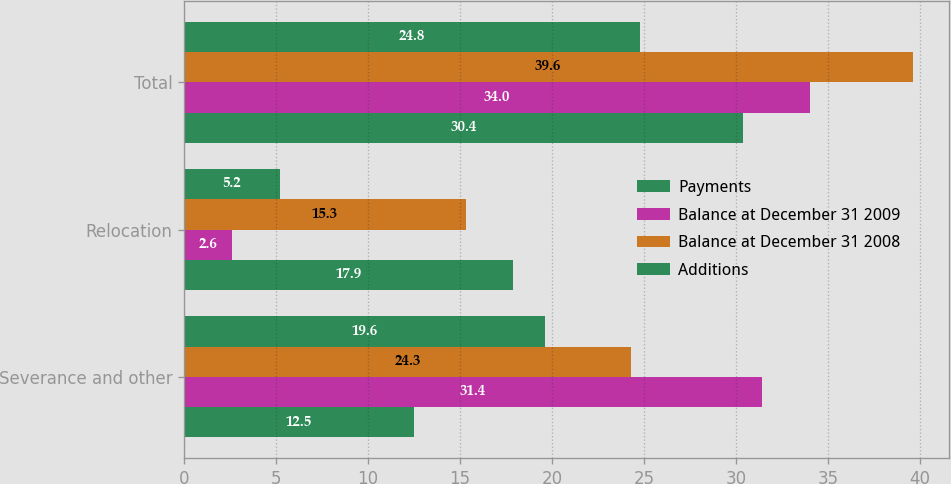Convert chart. <chart><loc_0><loc_0><loc_500><loc_500><stacked_bar_chart><ecel><fcel>Severance and other<fcel>Relocation<fcel>Total<nl><fcel>Payments<fcel>12.5<fcel>17.9<fcel>30.4<nl><fcel>Balance at December 31 2009<fcel>31.4<fcel>2.6<fcel>34<nl><fcel>Balance at December 31 2008<fcel>24.3<fcel>15.3<fcel>39.6<nl><fcel>Additions<fcel>19.6<fcel>5.2<fcel>24.8<nl></chart> 